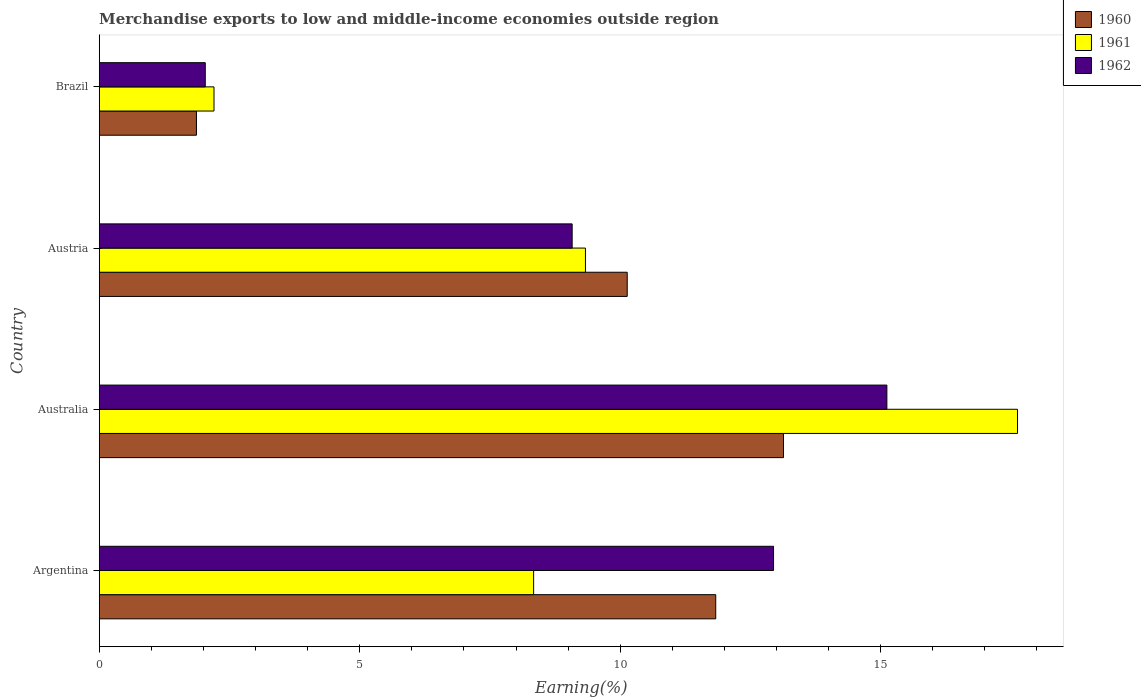How many bars are there on the 3rd tick from the bottom?
Your answer should be compact. 3. What is the label of the 4th group of bars from the top?
Offer a terse response. Argentina. In how many cases, is the number of bars for a given country not equal to the number of legend labels?
Keep it short and to the point. 0. What is the percentage of amount earned from merchandise exports in 1962 in Brazil?
Your answer should be compact. 2.04. Across all countries, what is the maximum percentage of amount earned from merchandise exports in 1962?
Keep it short and to the point. 15.12. Across all countries, what is the minimum percentage of amount earned from merchandise exports in 1962?
Ensure brevity in your answer.  2.04. In which country was the percentage of amount earned from merchandise exports in 1960 minimum?
Ensure brevity in your answer.  Brazil. What is the total percentage of amount earned from merchandise exports in 1962 in the graph?
Offer a terse response. 39.18. What is the difference between the percentage of amount earned from merchandise exports in 1960 in Austria and that in Brazil?
Keep it short and to the point. 8.27. What is the difference between the percentage of amount earned from merchandise exports in 1960 in Argentina and the percentage of amount earned from merchandise exports in 1962 in Brazil?
Make the answer very short. 9.8. What is the average percentage of amount earned from merchandise exports in 1961 per country?
Give a very brief answer. 9.38. What is the difference between the percentage of amount earned from merchandise exports in 1960 and percentage of amount earned from merchandise exports in 1962 in Argentina?
Your answer should be very brief. -1.11. In how many countries, is the percentage of amount earned from merchandise exports in 1961 greater than 11 %?
Offer a terse response. 1. What is the ratio of the percentage of amount earned from merchandise exports in 1961 in Austria to that in Brazil?
Make the answer very short. 4.24. Is the difference between the percentage of amount earned from merchandise exports in 1960 in Australia and Austria greater than the difference between the percentage of amount earned from merchandise exports in 1962 in Australia and Austria?
Offer a very short reply. No. What is the difference between the highest and the second highest percentage of amount earned from merchandise exports in 1961?
Provide a succinct answer. 8.29. What is the difference between the highest and the lowest percentage of amount earned from merchandise exports in 1960?
Provide a short and direct response. 11.27. In how many countries, is the percentage of amount earned from merchandise exports in 1962 greater than the average percentage of amount earned from merchandise exports in 1962 taken over all countries?
Offer a very short reply. 2. Is the sum of the percentage of amount earned from merchandise exports in 1961 in Australia and Brazil greater than the maximum percentage of amount earned from merchandise exports in 1962 across all countries?
Your answer should be compact. Yes. What does the 1st bar from the top in Argentina represents?
Offer a very short reply. 1962. How many bars are there?
Give a very brief answer. 12. How many countries are there in the graph?
Your answer should be compact. 4. What is the difference between two consecutive major ticks on the X-axis?
Make the answer very short. 5. Does the graph contain any zero values?
Give a very brief answer. No. Does the graph contain grids?
Your answer should be compact. No. Where does the legend appear in the graph?
Ensure brevity in your answer.  Top right. How many legend labels are there?
Keep it short and to the point. 3. What is the title of the graph?
Your answer should be very brief. Merchandise exports to low and middle-income economies outside region. Does "1974" appear as one of the legend labels in the graph?
Your answer should be compact. No. What is the label or title of the X-axis?
Offer a very short reply. Earning(%). What is the Earning(%) in 1960 in Argentina?
Ensure brevity in your answer.  11.83. What is the Earning(%) of 1961 in Argentina?
Your answer should be compact. 8.34. What is the Earning(%) in 1962 in Argentina?
Make the answer very short. 12.94. What is the Earning(%) of 1960 in Australia?
Make the answer very short. 13.13. What is the Earning(%) in 1961 in Australia?
Keep it short and to the point. 17.63. What is the Earning(%) in 1962 in Australia?
Ensure brevity in your answer.  15.12. What is the Earning(%) of 1960 in Austria?
Offer a terse response. 10.13. What is the Earning(%) of 1961 in Austria?
Keep it short and to the point. 9.33. What is the Earning(%) in 1962 in Austria?
Your response must be concise. 9.08. What is the Earning(%) of 1960 in Brazil?
Make the answer very short. 1.87. What is the Earning(%) in 1961 in Brazil?
Provide a succinct answer. 2.2. What is the Earning(%) in 1962 in Brazil?
Provide a short and direct response. 2.04. Across all countries, what is the maximum Earning(%) of 1960?
Your answer should be compact. 13.13. Across all countries, what is the maximum Earning(%) in 1961?
Provide a short and direct response. 17.63. Across all countries, what is the maximum Earning(%) in 1962?
Your answer should be very brief. 15.12. Across all countries, what is the minimum Earning(%) of 1960?
Provide a succinct answer. 1.87. Across all countries, what is the minimum Earning(%) of 1961?
Offer a very short reply. 2.2. Across all countries, what is the minimum Earning(%) of 1962?
Provide a short and direct response. 2.04. What is the total Earning(%) of 1960 in the graph?
Offer a terse response. 36.97. What is the total Earning(%) of 1961 in the graph?
Give a very brief answer. 37.5. What is the total Earning(%) of 1962 in the graph?
Provide a short and direct response. 39.18. What is the difference between the Earning(%) in 1960 in Argentina and that in Australia?
Ensure brevity in your answer.  -1.3. What is the difference between the Earning(%) in 1961 in Argentina and that in Australia?
Offer a terse response. -9.29. What is the difference between the Earning(%) of 1962 in Argentina and that in Australia?
Keep it short and to the point. -2.18. What is the difference between the Earning(%) in 1960 in Argentina and that in Austria?
Make the answer very short. 1.7. What is the difference between the Earning(%) of 1961 in Argentina and that in Austria?
Your answer should be very brief. -0.99. What is the difference between the Earning(%) of 1962 in Argentina and that in Austria?
Provide a short and direct response. 3.87. What is the difference between the Earning(%) in 1960 in Argentina and that in Brazil?
Your answer should be compact. 9.97. What is the difference between the Earning(%) in 1961 in Argentina and that in Brazil?
Provide a short and direct response. 6.14. What is the difference between the Earning(%) in 1962 in Argentina and that in Brazil?
Ensure brevity in your answer.  10.91. What is the difference between the Earning(%) in 1960 in Australia and that in Austria?
Offer a very short reply. 3. What is the difference between the Earning(%) of 1961 in Australia and that in Austria?
Offer a terse response. 8.29. What is the difference between the Earning(%) in 1962 in Australia and that in Austria?
Your answer should be compact. 6.04. What is the difference between the Earning(%) in 1960 in Australia and that in Brazil?
Your answer should be compact. 11.27. What is the difference between the Earning(%) in 1961 in Australia and that in Brazil?
Provide a succinct answer. 15.42. What is the difference between the Earning(%) of 1962 in Australia and that in Brazil?
Give a very brief answer. 13.08. What is the difference between the Earning(%) in 1960 in Austria and that in Brazil?
Ensure brevity in your answer.  8.27. What is the difference between the Earning(%) in 1961 in Austria and that in Brazil?
Your response must be concise. 7.13. What is the difference between the Earning(%) of 1962 in Austria and that in Brazil?
Give a very brief answer. 7.04. What is the difference between the Earning(%) of 1960 in Argentina and the Earning(%) of 1961 in Australia?
Provide a short and direct response. -5.79. What is the difference between the Earning(%) of 1960 in Argentina and the Earning(%) of 1962 in Australia?
Give a very brief answer. -3.29. What is the difference between the Earning(%) in 1961 in Argentina and the Earning(%) in 1962 in Australia?
Your answer should be very brief. -6.78. What is the difference between the Earning(%) of 1960 in Argentina and the Earning(%) of 1961 in Austria?
Keep it short and to the point. 2.5. What is the difference between the Earning(%) in 1960 in Argentina and the Earning(%) in 1962 in Austria?
Your response must be concise. 2.76. What is the difference between the Earning(%) of 1961 in Argentina and the Earning(%) of 1962 in Austria?
Your answer should be compact. -0.74. What is the difference between the Earning(%) of 1960 in Argentina and the Earning(%) of 1961 in Brazil?
Offer a very short reply. 9.63. What is the difference between the Earning(%) of 1960 in Argentina and the Earning(%) of 1962 in Brazil?
Offer a terse response. 9.8. What is the difference between the Earning(%) of 1961 in Argentina and the Earning(%) of 1962 in Brazil?
Give a very brief answer. 6.3. What is the difference between the Earning(%) in 1960 in Australia and the Earning(%) in 1961 in Austria?
Offer a terse response. 3.8. What is the difference between the Earning(%) in 1960 in Australia and the Earning(%) in 1962 in Austria?
Your response must be concise. 4.06. What is the difference between the Earning(%) in 1961 in Australia and the Earning(%) in 1962 in Austria?
Your response must be concise. 8.55. What is the difference between the Earning(%) of 1960 in Australia and the Earning(%) of 1961 in Brazil?
Provide a short and direct response. 10.93. What is the difference between the Earning(%) of 1960 in Australia and the Earning(%) of 1962 in Brazil?
Offer a very short reply. 11.1. What is the difference between the Earning(%) in 1961 in Australia and the Earning(%) in 1962 in Brazil?
Provide a succinct answer. 15.59. What is the difference between the Earning(%) of 1960 in Austria and the Earning(%) of 1961 in Brazil?
Offer a very short reply. 7.93. What is the difference between the Earning(%) of 1960 in Austria and the Earning(%) of 1962 in Brazil?
Give a very brief answer. 8.1. What is the difference between the Earning(%) in 1961 in Austria and the Earning(%) in 1962 in Brazil?
Keep it short and to the point. 7.3. What is the average Earning(%) in 1960 per country?
Make the answer very short. 9.24. What is the average Earning(%) of 1961 per country?
Your answer should be very brief. 9.38. What is the average Earning(%) of 1962 per country?
Your answer should be compact. 9.79. What is the difference between the Earning(%) in 1960 and Earning(%) in 1961 in Argentina?
Your response must be concise. 3.5. What is the difference between the Earning(%) in 1960 and Earning(%) in 1962 in Argentina?
Your response must be concise. -1.11. What is the difference between the Earning(%) in 1961 and Earning(%) in 1962 in Argentina?
Keep it short and to the point. -4.61. What is the difference between the Earning(%) in 1960 and Earning(%) in 1961 in Australia?
Keep it short and to the point. -4.49. What is the difference between the Earning(%) of 1960 and Earning(%) of 1962 in Australia?
Offer a terse response. -1.98. What is the difference between the Earning(%) in 1961 and Earning(%) in 1962 in Australia?
Your response must be concise. 2.51. What is the difference between the Earning(%) of 1960 and Earning(%) of 1961 in Austria?
Ensure brevity in your answer.  0.8. What is the difference between the Earning(%) in 1960 and Earning(%) in 1962 in Austria?
Make the answer very short. 1.06. What is the difference between the Earning(%) of 1961 and Earning(%) of 1962 in Austria?
Keep it short and to the point. 0.26. What is the difference between the Earning(%) of 1960 and Earning(%) of 1961 in Brazil?
Keep it short and to the point. -0.34. What is the difference between the Earning(%) in 1960 and Earning(%) in 1962 in Brazil?
Keep it short and to the point. -0.17. What is the difference between the Earning(%) of 1961 and Earning(%) of 1962 in Brazil?
Ensure brevity in your answer.  0.17. What is the ratio of the Earning(%) of 1960 in Argentina to that in Australia?
Your response must be concise. 0.9. What is the ratio of the Earning(%) of 1961 in Argentina to that in Australia?
Your answer should be compact. 0.47. What is the ratio of the Earning(%) in 1962 in Argentina to that in Australia?
Offer a terse response. 0.86. What is the ratio of the Earning(%) in 1960 in Argentina to that in Austria?
Offer a terse response. 1.17. What is the ratio of the Earning(%) in 1961 in Argentina to that in Austria?
Provide a succinct answer. 0.89. What is the ratio of the Earning(%) of 1962 in Argentina to that in Austria?
Keep it short and to the point. 1.43. What is the ratio of the Earning(%) in 1960 in Argentina to that in Brazil?
Offer a very short reply. 6.34. What is the ratio of the Earning(%) in 1961 in Argentina to that in Brazil?
Offer a terse response. 3.78. What is the ratio of the Earning(%) of 1962 in Argentina to that in Brazil?
Your response must be concise. 6.36. What is the ratio of the Earning(%) of 1960 in Australia to that in Austria?
Make the answer very short. 1.3. What is the ratio of the Earning(%) in 1961 in Australia to that in Austria?
Offer a terse response. 1.89. What is the ratio of the Earning(%) of 1962 in Australia to that in Austria?
Your answer should be very brief. 1.67. What is the ratio of the Earning(%) of 1960 in Australia to that in Brazil?
Give a very brief answer. 7.04. What is the ratio of the Earning(%) of 1961 in Australia to that in Brazil?
Offer a very short reply. 8. What is the ratio of the Earning(%) of 1962 in Australia to that in Brazil?
Your answer should be compact. 7.43. What is the ratio of the Earning(%) in 1960 in Austria to that in Brazil?
Your response must be concise. 5.43. What is the ratio of the Earning(%) in 1961 in Austria to that in Brazil?
Provide a succinct answer. 4.24. What is the ratio of the Earning(%) in 1962 in Austria to that in Brazil?
Keep it short and to the point. 4.46. What is the difference between the highest and the second highest Earning(%) of 1960?
Provide a short and direct response. 1.3. What is the difference between the highest and the second highest Earning(%) of 1961?
Offer a terse response. 8.29. What is the difference between the highest and the second highest Earning(%) of 1962?
Offer a terse response. 2.18. What is the difference between the highest and the lowest Earning(%) of 1960?
Your response must be concise. 11.27. What is the difference between the highest and the lowest Earning(%) of 1961?
Your answer should be very brief. 15.42. What is the difference between the highest and the lowest Earning(%) of 1962?
Offer a terse response. 13.08. 